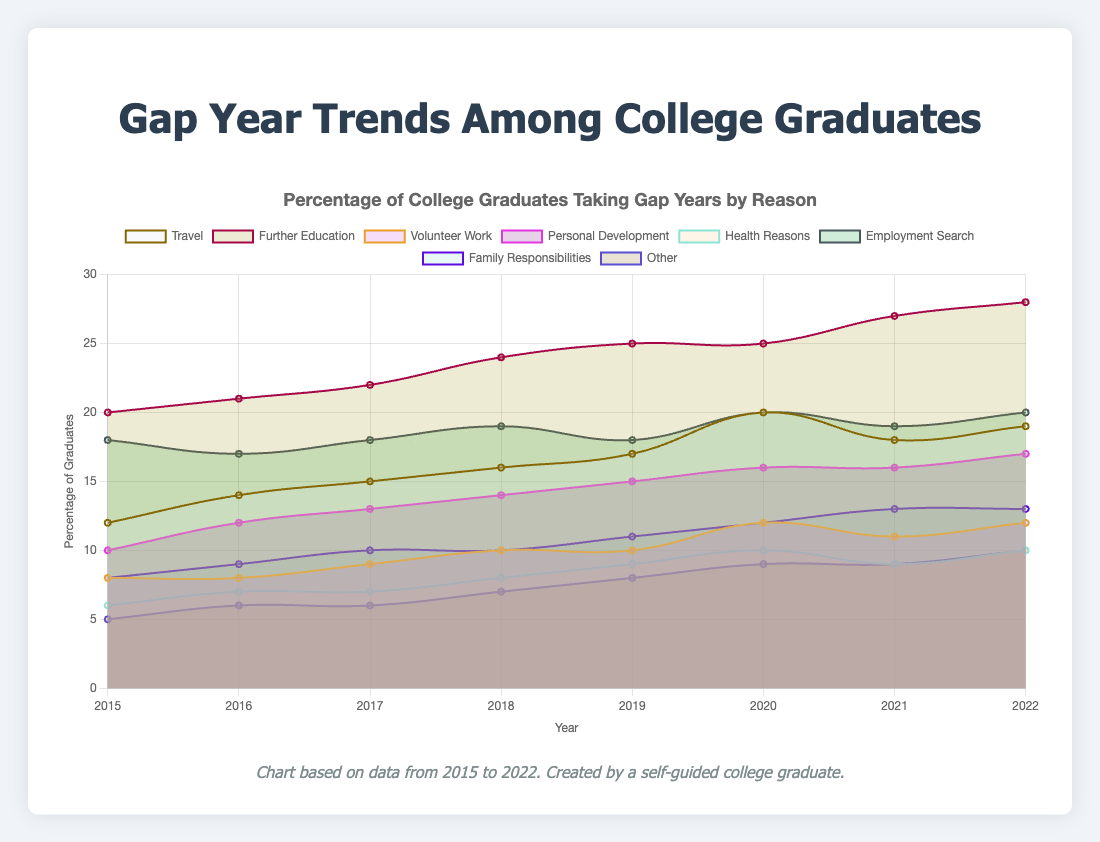What's the title of the chart? The title of the chart is displayed at the top and reads "Percentage of College Graduates Taking Gap Years by Reason".
Answer: Percentage of College Graduates Taking Gap Years by Reason Which category shows the highest percentage in 2022? By looking at the data point for 2022, the category "Further Education" has the highest percentage value at 28%.
Answer: Further Education In which year did the "Travel" category see the highest percentage? The "Travel" category line shows the highest point in 2020 at 20%, according to the visual data.
Answer: 2020 Compare the percentages of "Volunteer Work" and "Employment Search" in 2019. Which one is higher? By visually comparing the data points for 2019 on those two lines, "Employment Search" at 18% is higher than "Volunteer Work" at 10%.
Answer: Employment Search What is the average percentage for the "Personal Development" category over the years presented? Sum the percentages for "Personal Development" across all years (10 + 12 + 13 + 14 + 15 + 16 + 16 + 17 = 113) and then divide by the number of years (113 / 8) to get an average of 14.125%.
Answer: 14.125% By how much did the "Family Responsibilities" category increase from 2015 to 2022? Subtract the percentage for 2015 (8%) from the percentage for 2022 (13%) to find the increase, which is 13% - 8% = 5%.
Answer: 5% Which year saw an equal percentage of college graduates taking gap years for "Travel" and "Volunteer Work"? Visually inspecting the chart, in 2019 both "Travel" and "Volunteer Work" categories record the same percentage value of 10%.
Answer: 2019 Which category had the smallest percentage change from 2015 to 2022? To find the smallest change, calculate the absolute difference for each category over the years and compare: "Travel" 19-12=7, "Further Education" 28-20=8, "Volunteer Work" 12-8=4, "Personal Development" 17-10=7, "Health Reasons" 10-6=4, "Employment Search" 20-18=2, "Family Responsibilities" 13-8=5, "Other" 10-5=5. The smallest change is in "Employment Search" with 2%.
Answer: Employment Search 